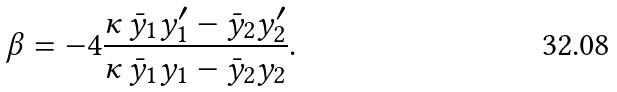Convert formula to latex. <formula><loc_0><loc_0><loc_500><loc_500>\beta = - 4 \frac { \kappa \, \bar { y } _ { 1 } y _ { 1 } ^ { \prime } - \bar { y } _ { 2 } y _ { 2 } ^ { \prime } } { \kappa \, \bar { y } _ { 1 } y _ { 1 } - \bar { y } _ { 2 } y _ { 2 } } .</formula> 